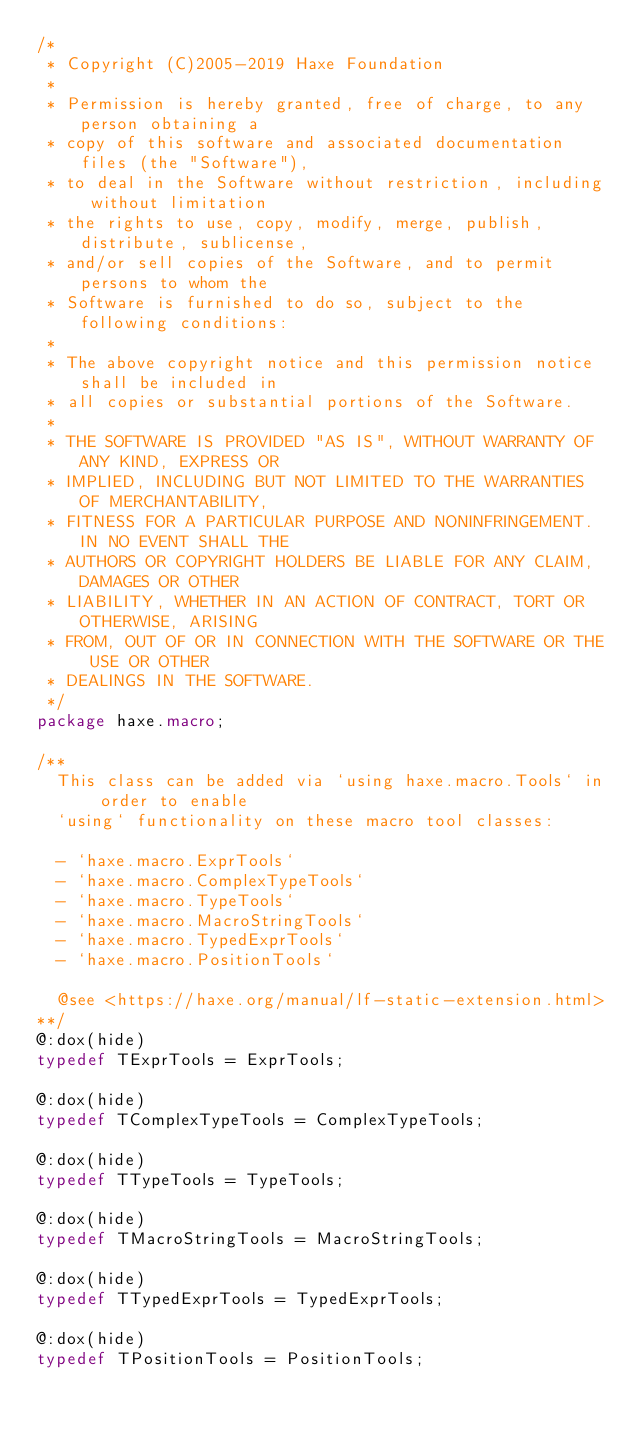Convert code to text. <code><loc_0><loc_0><loc_500><loc_500><_Haxe_>/*
 * Copyright (C)2005-2019 Haxe Foundation
 *
 * Permission is hereby granted, free of charge, to any person obtaining a
 * copy of this software and associated documentation files (the "Software"),
 * to deal in the Software without restriction, including without limitation
 * the rights to use, copy, modify, merge, publish, distribute, sublicense,
 * and/or sell copies of the Software, and to permit persons to whom the
 * Software is furnished to do so, subject to the following conditions:
 *
 * The above copyright notice and this permission notice shall be included in
 * all copies or substantial portions of the Software.
 *
 * THE SOFTWARE IS PROVIDED "AS IS", WITHOUT WARRANTY OF ANY KIND, EXPRESS OR
 * IMPLIED, INCLUDING BUT NOT LIMITED TO THE WARRANTIES OF MERCHANTABILITY,
 * FITNESS FOR A PARTICULAR PURPOSE AND NONINFRINGEMENT. IN NO EVENT SHALL THE
 * AUTHORS OR COPYRIGHT HOLDERS BE LIABLE FOR ANY CLAIM, DAMAGES OR OTHER
 * LIABILITY, WHETHER IN AN ACTION OF CONTRACT, TORT OR OTHERWISE, ARISING
 * FROM, OUT OF OR IN CONNECTION WITH THE SOFTWARE OR THE USE OR OTHER
 * DEALINGS IN THE SOFTWARE.
 */
package haxe.macro;

/**
	This class can be added via `using haxe.macro.Tools` in order to enable
	`using` functionality on these macro tool classes:

	- `haxe.macro.ExprTools`
	- `haxe.macro.ComplexTypeTools`
	- `haxe.macro.TypeTools`
	- `haxe.macro.MacroStringTools`
	- `haxe.macro.TypedExprTools`
	- `haxe.macro.PositionTools`
  
  @see <https://haxe.org/manual/lf-static-extension.html>
**/
@:dox(hide)
typedef TExprTools = ExprTools;

@:dox(hide)
typedef TComplexTypeTools = ComplexTypeTools;

@:dox(hide)
typedef TTypeTools = TypeTools;

@:dox(hide)
typedef TMacroStringTools = MacroStringTools;

@:dox(hide)
typedef TTypedExprTools = TypedExprTools;

@:dox(hide)
typedef TPositionTools = PositionTools;
</code> 